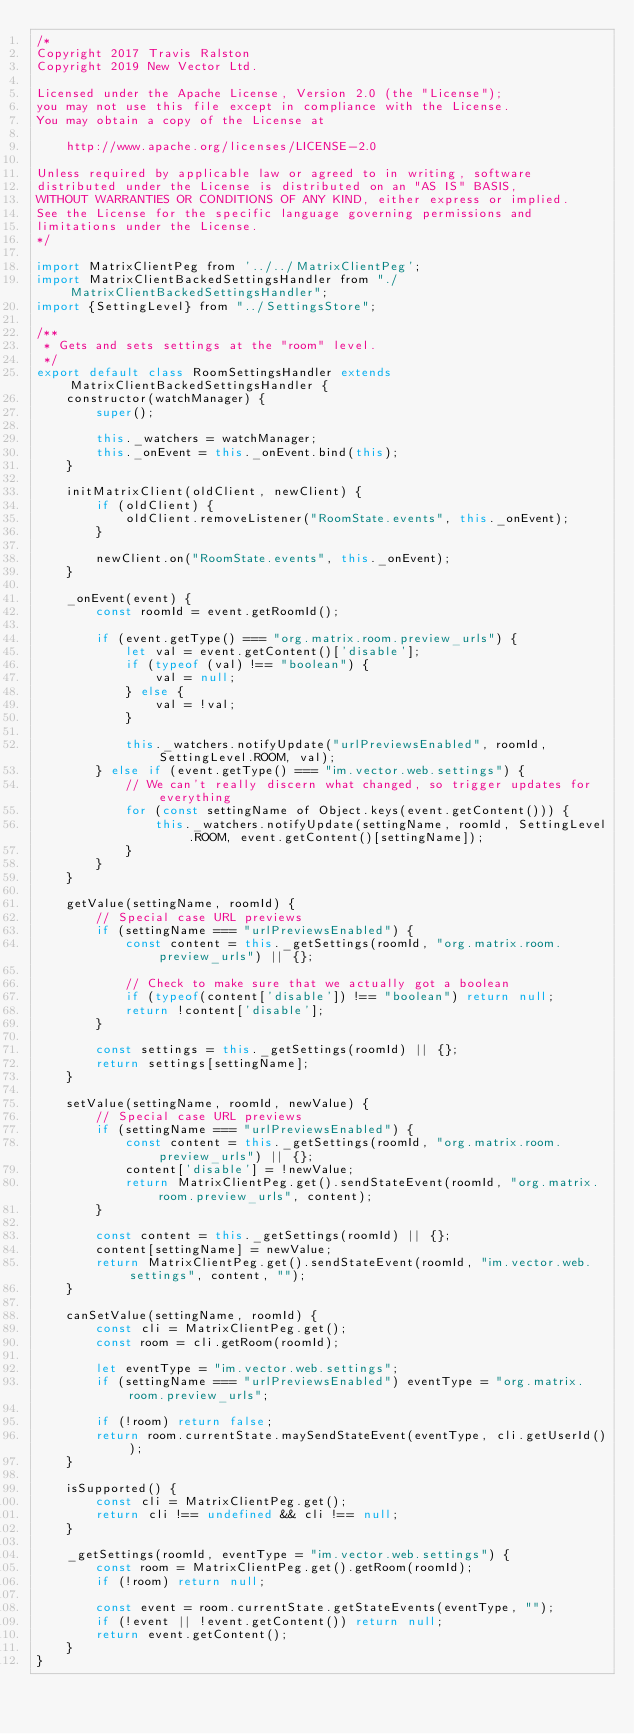<code> <loc_0><loc_0><loc_500><loc_500><_JavaScript_>/*
Copyright 2017 Travis Ralston
Copyright 2019 New Vector Ltd.

Licensed under the Apache License, Version 2.0 (the "License");
you may not use this file except in compliance with the License.
You may obtain a copy of the License at

    http://www.apache.org/licenses/LICENSE-2.0

Unless required by applicable law or agreed to in writing, software
distributed under the License is distributed on an "AS IS" BASIS,
WITHOUT WARRANTIES OR CONDITIONS OF ANY KIND, either express or implied.
See the License for the specific language governing permissions and
limitations under the License.
*/

import MatrixClientPeg from '../../MatrixClientPeg';
import MatrixClientBackedSettingsHandler from "./MatrixClientBackedSettingsHandler";
import {SettingLevel} from "../SettingsStore";

/**
 * Gets and sets settings at the "room" level.
 */
export default class RoomSettingsHandler extends MatrixClientBackedSettingsHandler {
    constructor(watchManager) {
        super();

        this._watchers = watchManager;
        this._onEvent = this._onEvent.bind(this);
    }

    initMatrixClient(oldClient, newClient) {
        if (oldClient) {
            oldClient.removeListener("RoomState.events", this._onEvent);
        }

        newClient.on("RoomState.events", this._onEvent);
    }

    _onEvent(event) {
        const roomId = event.getRoomId();

        if (event.getType() === "org.matrix.room.preview_urls") {
            let val = event.getContent()['disable'];
            if (typeof (val) !== "boolean") {
                val = null;
            } else {
                val = !val;
            }

            this._watchers.notifyUpdate("urlPreviewsEnabled", roomId, SettingLevel.ROOM, val);
        } else if (event.getType() === "im.vector.web.settings") {
            // We can't really discern what changed, so trigger updates for everything
            for (const settingName of Object.keys(event.getContent())) {
                this._watchers.notifyUpdate(settingName, roomId, SettingLevel.ROOM, event.getContent()[settingName]);
            }
        }
    }

    getValue(settingName, roomId) {
        // Special case URL previews
        if (settingName === "urlPreviewsEnabled") {
            const content = this._getSettings(roomId, "org.matrix.room.preview_urls") || {};

            // Check to make sure that we actually got a boolean
            if (typeof(content['disable']) !== "boolean") return null;
            return !content['disable'];
        }

        const settings = this._getSettings(roomId) || {};
        return settings[settingName];
    }

    setValue(settingName, roomId, newValue) {
        // Special case URL previews
        if (settingName === "urlPreviewsEnabled") {
            const content = this._getSettings(roomId, "org.matrix.room.preview_urls") || {};
            content['disable'] = !newValue;
            return MatrixClientPeg.get().sendStateEvent(roomId, "org.matrix.room.preview_urls", content);
        }

        const content = this._getSettings(roomId) || {};
        content[settingName] = newValue;
        return MatrixClientPeg.get().sendStateEvent(roomId, "im.vector.web.settings", content, "");
    }

    canSetValue(settingName, roomId) {
        const cli = MatrixClientPeg.get();
        const room = cli.getRoom(roomId);

        let eventType = "im.vector.web.settings";
        if (settingName === "urlPreviewsEnabled") eventType = "org.matrix.room.preview_urls";

        if (!room) return false;
        return room.currentState.maySendStateEvent(eventType, cli.getUserId());
    }

    isSupported() {
        const cli = MatrixClientPeg.get();
        return cli !== undefined && cli !== null;
    }

    _getSettings(roomId, eventType = "im.vector.web.settings") {
        const room = MatrixClientPeg.get().getRoom(roomId);
        if (!room) return null;

        const event = room.currentState.getStateEvents(eventType, "");
        if (!event || !event.getContent()) return null;
        return event.getContent();
    }
}
</code> 